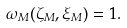<formula> <loc_0><loc_0><loc_500><loc_500>\omega _ { M } ( \zeta _ { M } , \xi _ { M } ) = 1 .</formula> 